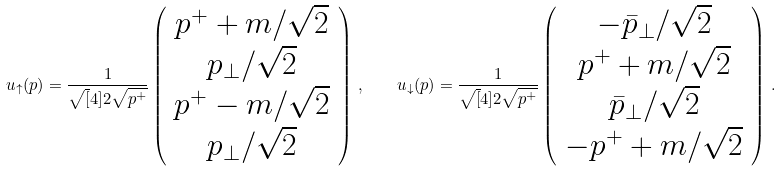Convert formula to latex. <formula><loc_0><loc_0><loc_500><loc_500>u _ { \uparrow } ( p ) = \frac { 1 } { \sqrt { [ } 4 ] { 2 } \sqrt { p ^ { + } } } \left ( \begin{array} { c } p ^ { + } + m / \sqrt { 2 } \\ p _ { \perp } / \sqrt { 2 } \\ p ^ { + } - m / \sqrt { 2 } \\ p _ { \perp } / \sqrt { 2 } \end{array} \right ) \, , \quad u _ { \downarrow } ( p ) = \frac { 1 } { \sqrt { [ } 4 ] { 2 } \sqrt { p ^ { + } } } \left ( \begin{array} { c } - \bar { p } _ { \perp } / \sqrt { 2 } \\ p ^ { + } + m / \sqrt { 2 } \\ \bar { p } _ { \perp } / \sqrt { 2 } \\ - p ^ { + } + m / \sqrt { 2 } \end{array} \right ) \, .</formula> 